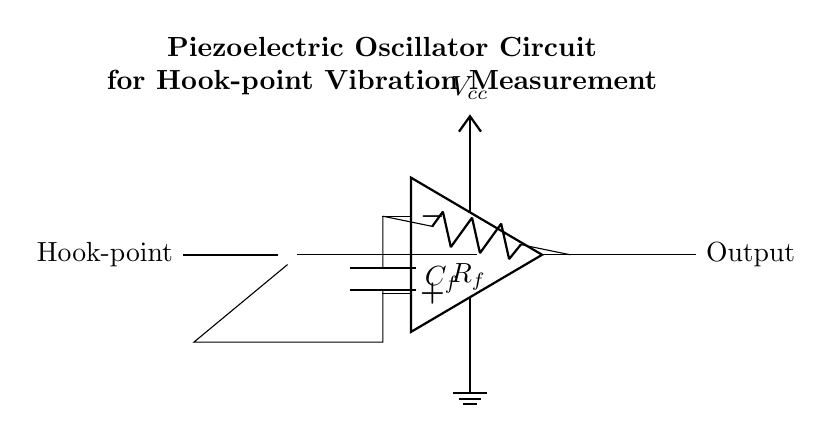What is the power supply voltage in this circuit? The power supply voltage is indicated as Vcc in the circuit diagram, which is connected to the upper terminal of the operational amplifier. This denotes the positive voltage supply for the circuit.
Answer: Vcc What type of component is used to sense vibrations at the hook-point? The component used to sense vibrations is the piezoelectric crystal, which is labeled as "Piezo Crystal" in the circuit diagram. It is responsible for converting mechanical vibrations into electrical signals.
Answer: Piezo Crystal How many reactive components are present in the circuit? The circuit contains two reactive components: a capacitor and the piezoelectric crystal (acting as a transducer). The capacitance is represented as C_f. This indicates there are two distinct reactive elements in the design.
Answer: Two What is the function of the feedback resistor in the oscillator circuit? The feedback resistor, labeled as R_f, provides necessary feedback from the output of the operational amplifier to its inverting input. This feedback is crucial for determining the gain and stability of the oscillator circuit's output.
Answer: Gain control Which component is responsible for amplification in this circuit? The component responsible for amplification is the operational amplifier, which is drawn in the circuit as a block labeled as "op amp." It receives the signal from the piezoelectric crystal and amplifies it for output.
Answer: Operational amplifier What is the output path for the signal in this circuit? The output path for the signal is indicated by the line that extends from the output of the operational amplifier (OP.out) to the right. This signifies where the measured signal is outputted from the circuit.
Answer: Output What kind of analysis is expected from this piezoelectric oscillator circuit? The expected analysis from this circuit is the measurement of precise vibrations at the hook-point using the piezoelectric sensor, which translates physical movement into an electrical signal for further analysis.
Answer: Vibration measurement 